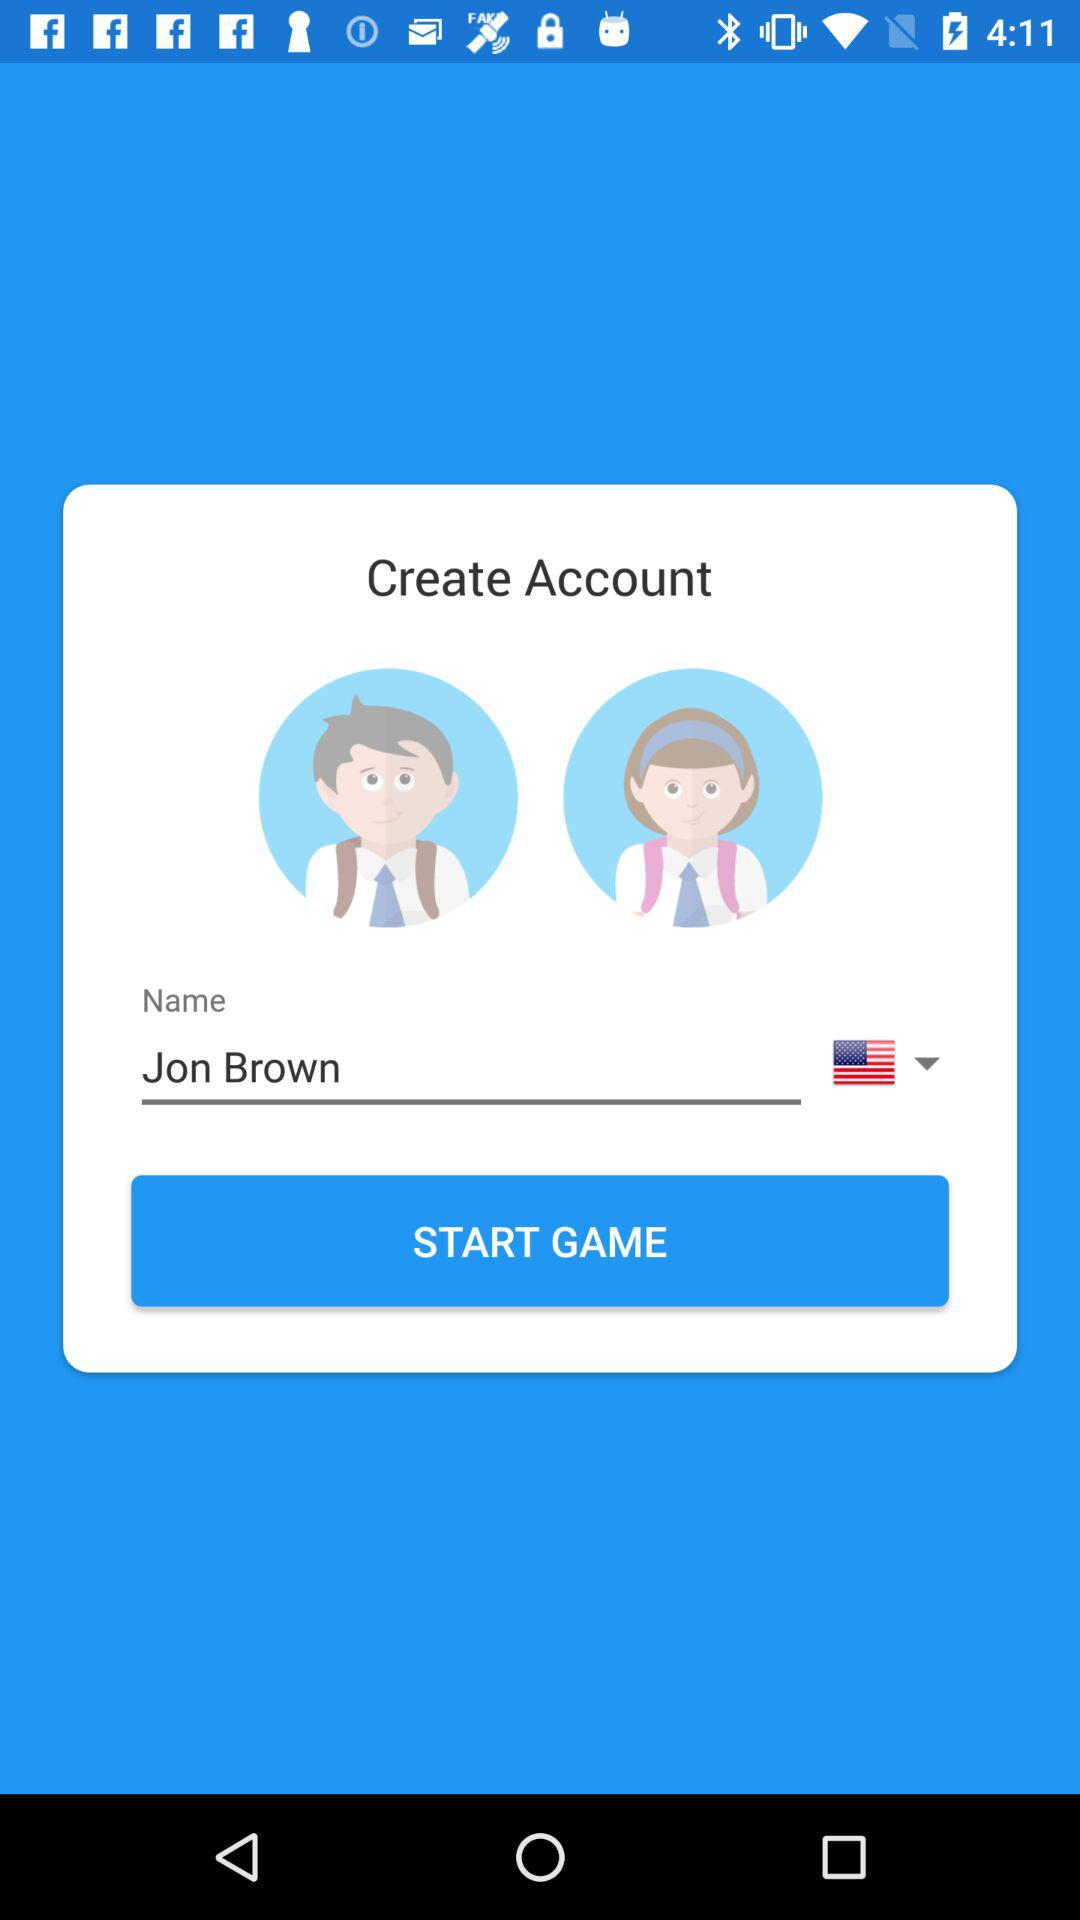What is the user's name? The user's name is Jon Brown. 